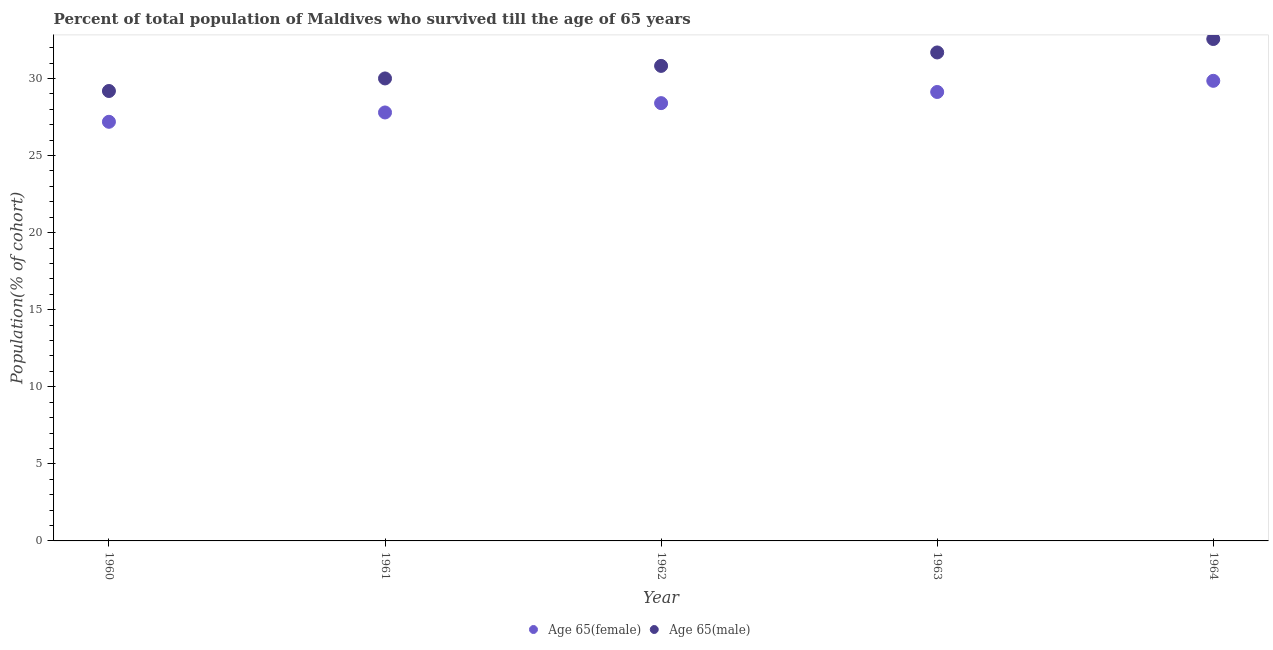How many different coloured dotlines are there?
Ensure brevity in your answer.  2. Is the number of dotlines equal to the number of legend labels?
Your response must be concise. Yes. What is the percentage of female population who survived till age of 65 in 1963?
Your response must be concise. 29.12. Across all years, what is the maximum percentage of female population who survived till age of 65?
Your response must be concise. 29.85. Across all years, what is the minimum percentage of female population who survived till age of 65?
Your answer should be very brief. 27.19. In which year was the percentage of female population who survived till age of 65 maximum?
Provide a short and direct response. 1964. In which year was the percentage of male population who survived till age of 65 minimum?
Provide a succinct answer. 1960. What is the total percentage of male population who survived till age of 65 in the graph?
Give a very brief answer. 154.25. What is the difference between the percentage of female population who survived till age of 65 in 1963 and that in 1964?
Make the answer very short. -0.72. What is the difference between the percentage of female population who survived till age of 65 in 1960 and the percentage of male population who survived till age of 65 in 1963?
Your answer should be very brief. -4.5. What is the average percentage of female population who survived till age of 65 per year?
Provide a short and direct response. 28.47. In the year 1961, what is the difference between the percentage of female population who survived till age of 65 and percentage of male population who survived till age of 65?
Keep it short and to the point. -2.21. In how many years, is the percentage of female population who survived till age of 65 greater than 25 %?
Give a very brief answer. 5. What is the ratio of the percentage of male population who survived till age of 65 in 1960 to that in 1961?
Provide a succinct answer. 0.97. What is the difference between the highest and the second highest percentage of male population who survived till age of 65?
Offer a very short reply. 0.87. What is the difference between the highest and the lowest percentage of male population who survived till age of 65?
Offer a very short reply. 3.37. In how many years, is the percentage of male population who survived till age of 65 greater than the average percentage of male population who survived till age of 65 taken over all years?
Keep it short and to the point. 2. Is the sum of the percentage of female population who survived till age of 65 in 1960 and 1961 greater than the maximum percentage of male population who survived till age of 65 across all years?
Offer a terse response. Yes. Is the percentage of male population who survived till age of 65 strictly less than the percentage of female population who survived till age of 65 over the years?
Offer a very short reply. No. How many dotlines are there?
Make the answer very short. 2. How many years are there in the graph?
Your response must be concise. 5. Does the graph contain any zero values?
Your answer should be very brief. No. Does the graph contain grids?
Provide a succinct answer. No. How many legend labels are there?
Your answer should be very brief. 2. What is the title of the graph?
Make the answer very short. Percent of total population of Maldives who survived till the age of 65 years. What is the label or title of the X-axis?
Make the answer very short. Year. What is the label or title of the Y-axis?
Your answer should be very brief. Population(% of cohort). What is the Population(% of cohort) in Age 65(female) in 1960?
Your answer should be very brief. 27.19. What is the Population(% of cohort) in Age 65(male) in 1960?
Ensure brevity in your answer.  29.19. What is the Population(% of cohort) in Age 65(female) in 1961?
Give a very brief answer. 27.79. What is the Population(% of cohort) in Age 65(male) in 1961?
Offer a very short reply. 30. What is the Population(% of cohort) of Age 65(female) in 1962?
Give a very brief answer. 28.4. What is the Population(% of cohort) in Age 65(male) in 1962?
Ensure brevity in your answer.  30.81. What is the Population(% of cohort) in Age 65(female) in 1963?
Provide a short and direct response. 29.12. What is the Population(% of cohort) in Age 65(male) in 1963?
Your answer should be compact. 31.69. What is the Population(% of cohort) in Age 65(female) in 1964?
Ensure brevity in your answer.  29.85. What is the Population(% of cohort) in Age 65(male) in 1964?
Your answer should be very brief. 32.56. Across all years, what is the maximum Population(% of cohort) in Age 65(female)?
Give a very brief answer. 29.85. Across all years, what is the maximum Population(% of cohort) in Age 65(male)?
Your answer should be very brief. 32.56. Across all years, what is the minimum Population(% of cohort) of Age 65(female)?
Provide a short and direct response. 27.19. Across all years, what is the minimum Population(% of cohort) in Age 65(male)?
Ensure brevity in your answer.  29.19. What is the total Population(% of cohort) in Age 65(female) in the graph?
Keep it short and to the point. 142.35. What is the total Population(% of cohort) in Age 65(male) in the graph?
Offer a terse response. 154.25. What is the difference between the Population(% of cohort) of Age 65(female) in 1960 and that in 1961?
Provide a succinct answer. -0.61. What is the difference between the Population(% of cohort) of Age 65(male) in 1960 and that in 1961?
Ensure brevity in your answer.  -0.81. What is the difference between the Population(% of cohort) of Age 65(female) in 1960 and that in 1962?
Your answer should be very brief. -1.21. What is the difference between the Population(% of cohort) in Age 65(male) in 1960 and that in 1962?
Provide a succinct answer. -1.63. What is the difference between the Population(% of cohort) in Age 65(female) in 1960 and that in 1963?
Give a very brief answer. -1.93. What is the difference between the Population(% of cohort) in Age 65(male) in 1960 and that in 1963?
Provide a short and direct response. -2.5. What is the difference between the Population(% of cohort) of Age 65(female) in 1960 and that in 1964?
Your answer should be compact. -2.66. What is the difference between the Population(% of cohort) in Age 65(male) in 1960 and that in 1964?
Keep it short and to the point. -3.37. What is the difference between the Population(% of cohort) in Age 65(female) in 1961 and that in 1962?
Provide a succinct answer. -0.61. What is the difference between the Population(% of cohort) in Age 65(male) in 1961 and that in 1962?
Keep it short and to the point. -0.81. What is the difference between the Population(% of cohort) in Age 65(female) in 1961 and that in 1963?
Provide a succinct answer. -1.33. What is the difference between the Population(% of cohort) of Age 65(male) in 1961 and that in 1963?
Make the answer very short. -1.69. What is the difference between the Population(% of cohort) of Age 65(female) in 1961 and that in 1964?
Provide a succinct answer. -2.05. What is the difference between the Population(% of cohort) in Age 65(male) in 1961 and that in 1964?
Provide a succinct answer. -2.56. What is the difference between the Population(% of cohort) in Age 65(female) in 1962 and that in 1963?
Offer a terse response. -0.72. What is the difference between the Population(% of cohort) of Age 65(male) in 1962 and that in 1963?
Offer a very short reply. -0.87. What is the difference between the Population(% of cohort) in Age 65(female) in 1962 and that in 1964?
Make the answer very short. -1.45. What is the difference between the Population(% of cohort) in Age 65(male) in 1962 and that in 1964?
Your response must be concise. -1.74. What is the difference between the Population(% of cohort) of Age 65(female) in 1963 and that in 1964?
Your response must be concise. -0.72. What is the difference between the Population(% of cohort) in Age 65(male) in 1963 and that in 1964?
Make the answer very short. -0.87. What is the difference between the Population(% of cohort) of Age 65(female) in 1960 and the Population(% of cohort) of Age 65(male) in 1961?
Give a very brief answer. -2.81. What is the difference between the Population(% of cohort) in Age 65(female) in 1960 and the Population(% of cohort) in Age 65(male) in 1962?
Your response must be concise. -3.63. What is the difference between the Population(% of cohort) in Age 65(female) in 1960 and the Population(% of cohort) in Age 65(male) in 1963?
Make the answer very short. -4.5. What is the difference between the Population(% of cohort) in Age 65(female) in 1960 and the Population(% of cohort) in Age 65(male) in 1964?
Your answer should be very brief. -5.37. What is the difference between the Population(% of cohort) in Age 65(female) in 1961 and the Population(% of cohort) in Age 65(male) in 1962?
Your answer should be compact. -3.02. What is the difference between the Population(% of cohort) in Age 65(female) in 1961 and the Population(% of cohort) in Age 65(male) in 1963?
Your answer should be compact. -3.89. What is the difference between the Population(% of cohort) of Age 65(female) in 1961 and the Population(% of cohort) of Age 65(male) in 1964?
Offer a terse response. -4.76. What is the difference between the Population(% of cohort) of Age 65(female) in 1962 and the Population(% of cohort) of Age 65(male) in 1963?
Make the answer very short. -3.29. What is the difference between the Population(% of cohort) of Age 65(female) in 1962 and the Population(% of cohort) of Age 65(male) in 1964?
Give a very brief answer. -4.16. What is the difference between the Population(% of cohort) in Age 65(female) in 1963 and the Population(% of cohort) in Age 65(male) in 1964?
Give a very brief answer. -3.44. What is the average Population(% of cohort) of Age 65(female) per year?
Offer a very short reply. 28.47. What is the average Population(% of cohort) in Age 65(male) per year?
Offer a terse response. 30.85. In the year 1960, what is the difference between the Population(% of cohort) in Age 65(female) and Population(% of cohort) in Age 65(male)?
Provide a short and direct response. -2. In the year 1961, what is the difference between the Population(% of cohort) in Age 65(female) and Population(% of cohort) in Age 65(male)?
Your answer should be compact. -2.21. In the year 1962, what is the difference between the Population(% of cohort) of Age 65(female) and Population(% of cohort) of Age 65(male)?
Give a very brief answer. -2.42. In the year 1963, what is the difference between the Population(% of cohort) of Age 65(female) and Population(% of cohort) of Age 65(male)?
Make the answer very short. -2.56. In the year 1964, what is the difference between the Population(% of cohort) in Age 65(female) and Population(% of cohort) in Age 65(male)?
Offer a very short reply. -2.71. What is the ratio of the Population(% of cohort) of Age 65(female) in 1960 to that in 1961?
Offer a terse response. 0.98. What is the ratio of the Population(% of cohort) of Age 65(male) in 1960 to that in 1961?
Your response must be concise. 0.97. What is the ratio of the Population(% of cohort) in Age 65(female) in 1960 to that in 1962?
Offer a very short reply. 0.96. What is the ratio of the Population(% of cohort) in Age 65(male) in 1960 to that in 1962?
Offer a very short reply. 0.95. What is the ratio of the Population(% of cohort) of Age 65(female) in 1960 to that in 1963?
Offer a very short reply. 0.93. What is the ratio of the Population(% of cohort) of Age 65(male) in 1960 to that in 1963?
Keep it short and to the point. 0.92. What is the ratio of the Population(% of cohort) in Age 65(female) in 1960 to that in 1964?
Offer a terse response. 0.91. What is the ratio of the Population(% of cohort) of Age 65(male) in 1960 to that in 1964?
Your response must be concise. 0.9. What is the ratio of the Population(% of cohort) of Age 65(female) in 1961 to that in 1962?
Offer a terse response. 0.98. What is the ratio of the Population(% of cohort) of Age 65(male) in 1961 to that in 1962?
Your answer should be compact. 0.97. What is the ratio of the Population(% of cohort) of Age 65(female) in 1961 to that in 1963?
Your answer should be compact. 0.95. What is the ratio of the Population(% of cohort) in Age 65(male) in 1961 to that in 1963?
Your answer should be very brief. 0.95. What is the ratio of the Population(% of cohort) of Age 65(female) in 1961 to that in 1964?
Make the answer very short. 0.93. What is the ratio of the Population(% of cohort) of Age 65(male) in 1961 to that in 1964?
Make the answer very short. 0.92. What is the ratio of the Population(% of cohort) in Age 65(female) in 1962 to that in 1963?
Your response must be concise. 0.98. What is the ratio of the Population(% of cohort) of Age 65(male) in 1962 to that in 1963?
Offer a terse response. 0.97. What is the ratio of the Population(% of cohort) of Age 65(female) in 1962 to that in 1964?
Keep it short and to the point. 0.95. What is the ratio of the Population(% of cohort) of Age 65(male) in 1962 to that in 1964?
Your answer should be very brief. 0.95. What is the ratio of the Population(% of cohort) of Age 65(female) in 1963 to that in 1964?
Provide a short and direct response. 0.98. What is the ratio of the Population(% of cohort) of Age 65(male) in 1963 to that in 1964?
Keep it short and to the point. 0.97. What is the difference between the highest and the second highest Population(% of cohort) in Age 65(female)?
Make the answer very short. 0.72. What is the difference between the highest and the second highest Population(% of cohort) in Age 65(male)?
Ensure brevity in your answer.  0.87. What is the difference between the highest and the lowest Population(% of cohort) of Age 65(female)?
Your answer should be very brief. 2.66. What is the difference between the highest and the lowest Population(% of cohort) in Age 65(male)?
Ensure brevity in your answer.  3.37. 